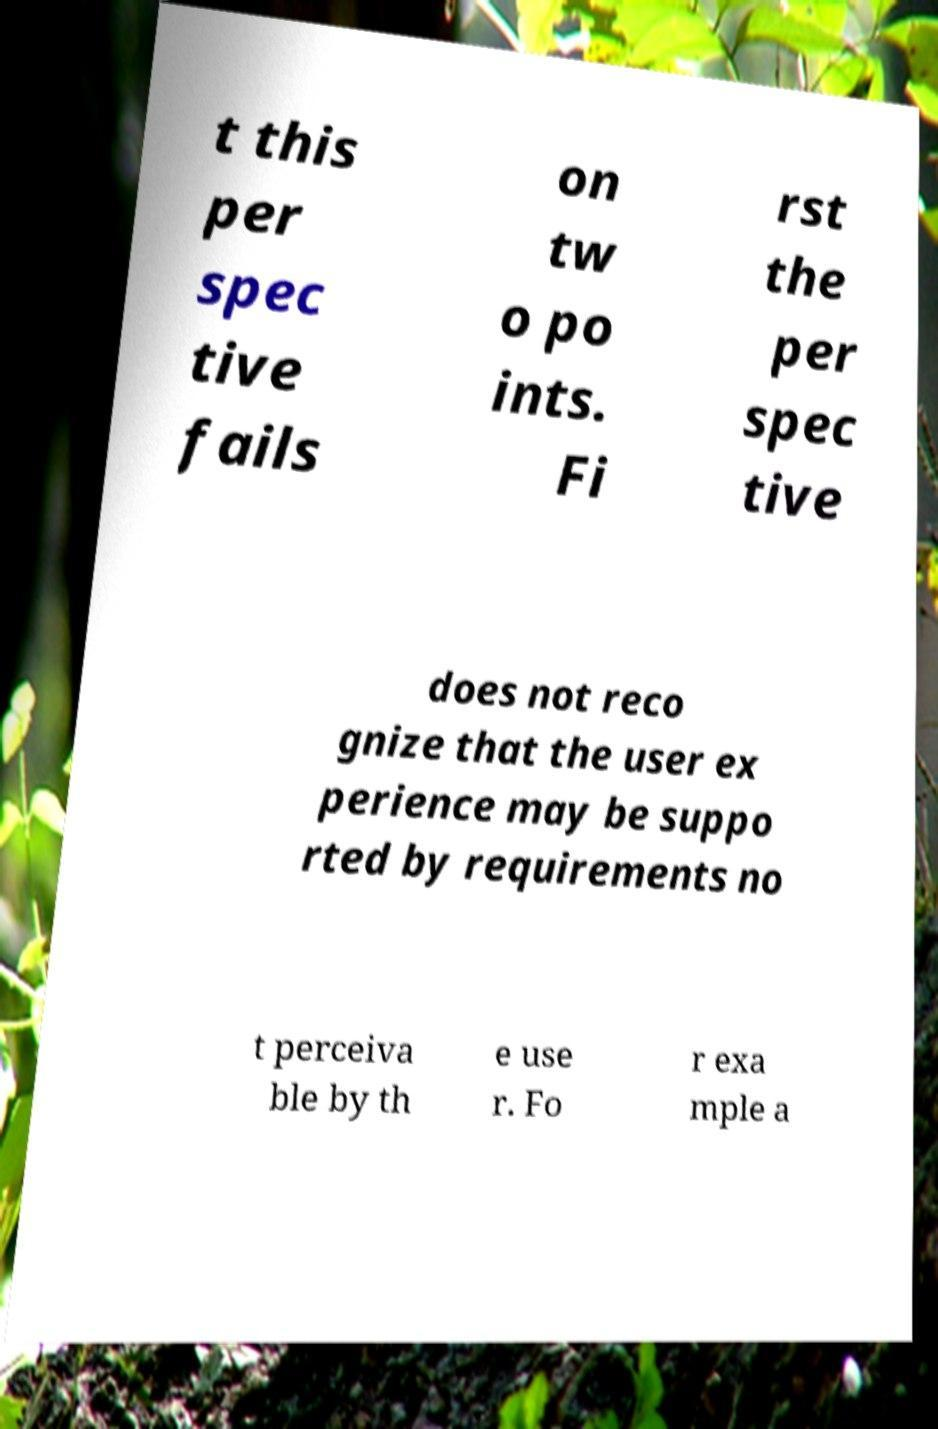I need the written content from this picture converted into text. Can you do that? t this per spec tive fails on tw o po ints. Fi rst the per spec tive does not reco gnize that the user ex perience may be suppo rted by requirements no t perceiva ble by th e use r. Fo r exa mple a 